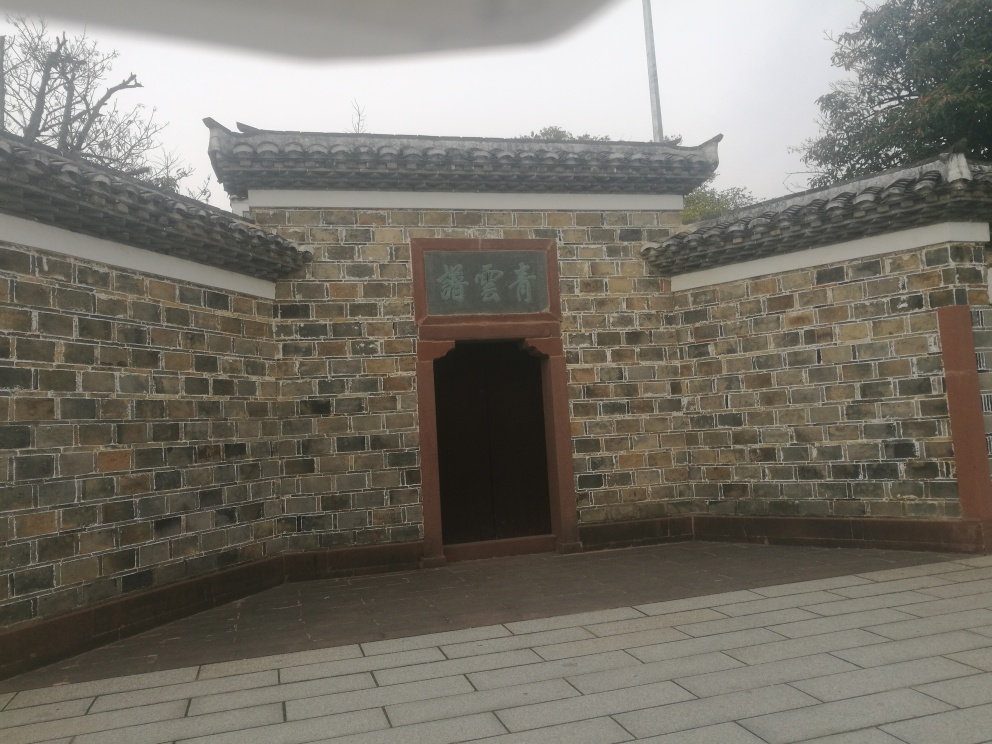What can you infer about the location and its surroundings based on the image? The architecture and the signage suggest the location could be in an area with historical significance, likely in a region influenced by East Asian cultural heritage. The open gate invites visitors, hinting at public access, like a park, temple, or historic site. The absence of foliage on the branches hints at a season which could be late autumn or winter, while the sky's overcast appearance suggests a possibly cooler and humid climate at the time the photo was taken. 